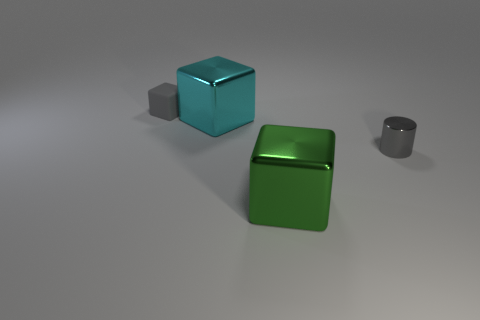Does the small gray rubber object have the same shape as the big green object?
Your answer should be compact. Yes. There is a small gray cylinder that is right of the tiny rubber thing; what number of cyan objects are in front of it?
Keep it short and to the point. 0. There is a green object that is the same material as the big cyan block; what is its shape?
Your answer should be compact. Cube. How many purple objects are either small objects or big blocks?
Provide a short and direct response. 0. Are there any large cyan cubes to the right of the large block behind the large metallic cube that is in front of the large cyan metallic object?
Keep it short and to the point. No. Are there fewer big cyan objects than large things?
Your answer should be very brief. Yes. There is a shiny thing behind the cylinder; is it the same shape as the big green thing?
Your response must be concise. Yes. Is there a big green metal object?
Ensure brevity in your answer.  Yes. The small object that is in front of the small gray cube that is to the left of the small gray object on the right side of the rubber object is what color?
Give a very brief answer. Gray. Is the number of big cyan metal things behind the cyan thing the same as the number of matte cubes that are on the right side of the small cube?
Provide a short and direct response. Yes. 